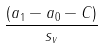Convert formula to latex. <formula><loc_0><loc_0><loc_500><loc_500>\frac { ( a _ { 1 } - a _ { 0 } - C ) } { s _ { v } }</formula> 